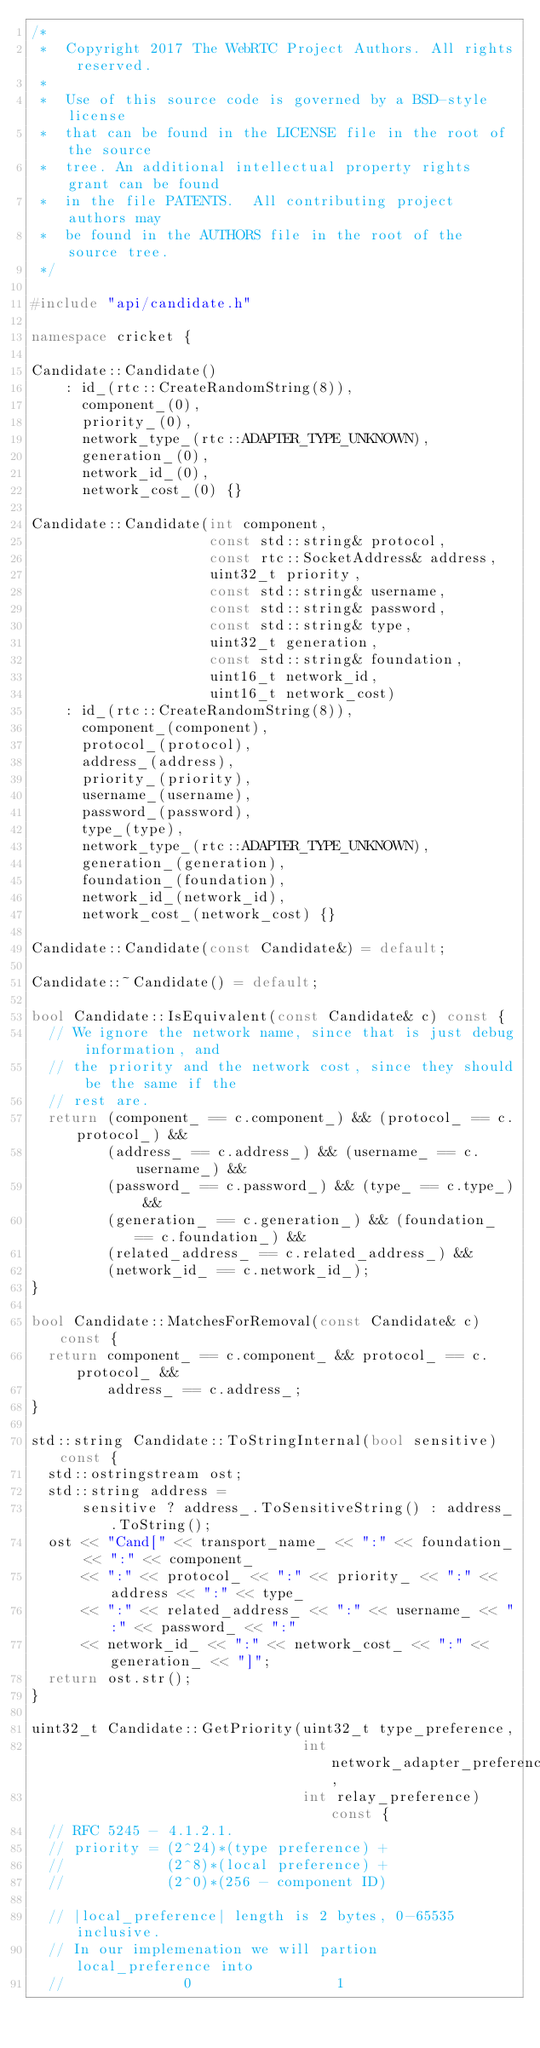Convert code to text. <code><loc_0><loc_0><loc_500><loc_500><_C++_>/*
 *  Copyright 2017 The WebRTC Project Authors. All rights reserved.
 *
 *  Use of this source code is governed by a BSD-style license
 *  that can be found in the LICENSE file in the root of the source
 *  tree. An additional intellectual property rights grant can be found
 *  in the file PATENTS.  All contributing project authors may
 *  be found in the AUTHORS file in the root of the source tree.
 */

#include "api/candidate.h"

namespace cricket {

Candidate::Candidate()
    : id_(rtc::CreateRandomString(8)),
      component_(0),
      priority_(0),
      network_type_(rtc::ADAPTER_TYPE_UNKNOWN),
      generation_(0),
      network_id_(0),
      network_cost_(0) {}

Candidate::Candidate(int component,
                     const std::string& protocol,
                     const rtc::SocketAddress& address,
                     uint32_t priority,
                     const std::string& username,
                     const std::string& password,
                     const std::string& type,
                     uint32_t generation,
                     const std::string& foundation,
                     uint16_t network_id,
                     uint16_t network_cost)
    : id_(rtc::CreateRandomString(8)),
      component_(component),
      protocol_(protocol),
      address_(address),
      priority_(priority),
      username_(username),
      password_(password),
      type_(type),
      network_type_(rtc::ADAPTER_TYPE_UNKNOWN),
      generation_(generation),
      foundation_(foundation),
      network_id_(network_id),
      network_cost_(network_cost) {}

Candidate::Candidate(const Candidate&) = default;

Candidate::~Candidate() = default;

bool Candidate::IsEquivalent(const Candidate& c) const {
  // We ignore the network name, since that is just debug information, and
  // the priority and the network cost, since they should be the same if the
  // rest are.
  return (component_ == c.component_) && (protocol_ == c.protocol_) &&
         (address_ == c.address_) && (username_ == c.username_) &&
         (password_ == c.password_) && (type_ == c.type_) &&
         (generation_ == c.generation_) && (foundation_ == c.foundation_) &&
         (related_address_ == c.related_address_) &&
         (network_id_ == c.network_id_);
}

bool Candidate::MatchesForRemoval(const Candidate& c) const {
  return component_ == c.component_ && protocol_ == c.protocol_ &&
         address_ == c.address_;
}

std::string Candidate::ToStringInternal(bool sensitive) const {
  std::ostringstream ost;
  std::string address =
      sensitive ? address_.ToSensitiveString() : address_.ToString();
  ost << "Cand[" << transport_name_ << ":" << foundation_ << ":" << component_
      << ":" << protocol_ << ":" << priority_ << ":" << address << ":" << type_
      << ":" << related_address_ << ":" << username_ << ":" << password_ << ":"
      << network_id_ << ":" << network_cost_ << ":" << generation_ << "]";
  return ost.str();
}

uint32_t Candidate::GetPriority(uint32_t type_preference,
                                int network_adapter_preference,
                                int relay_preference) const {
  // RFC 5245 - 4.1.2.1.
  // priority = (2^24)*(type preference) +
  //            (2^8)*(local preference) +
  //            (2^0)*(256 - component ID)

  // |local_preference| length is 2 bytes, 0-65535 inclusive.
  // In our implemenation we will partion local_preference into
  //              0                 1</code> 